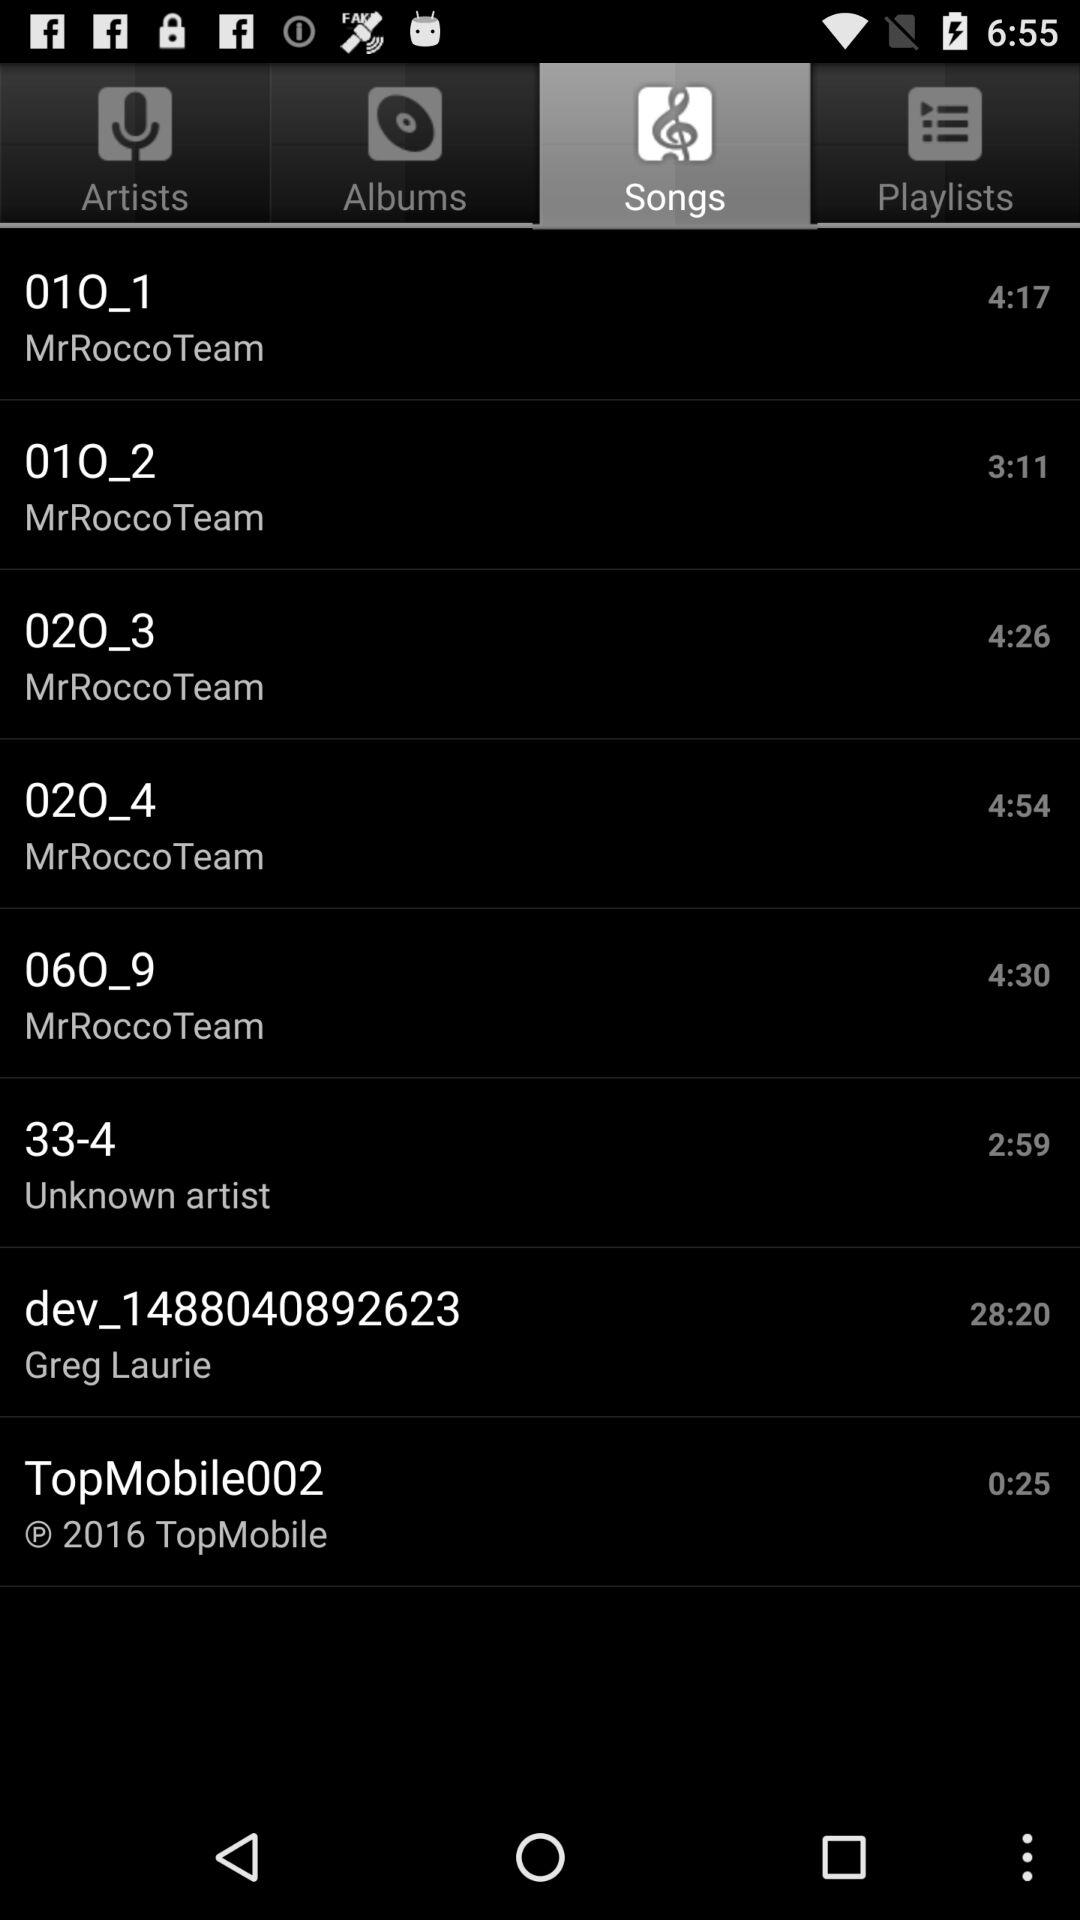What is the duration of the "TopMobile002" song? The duration is 25 seconds. 